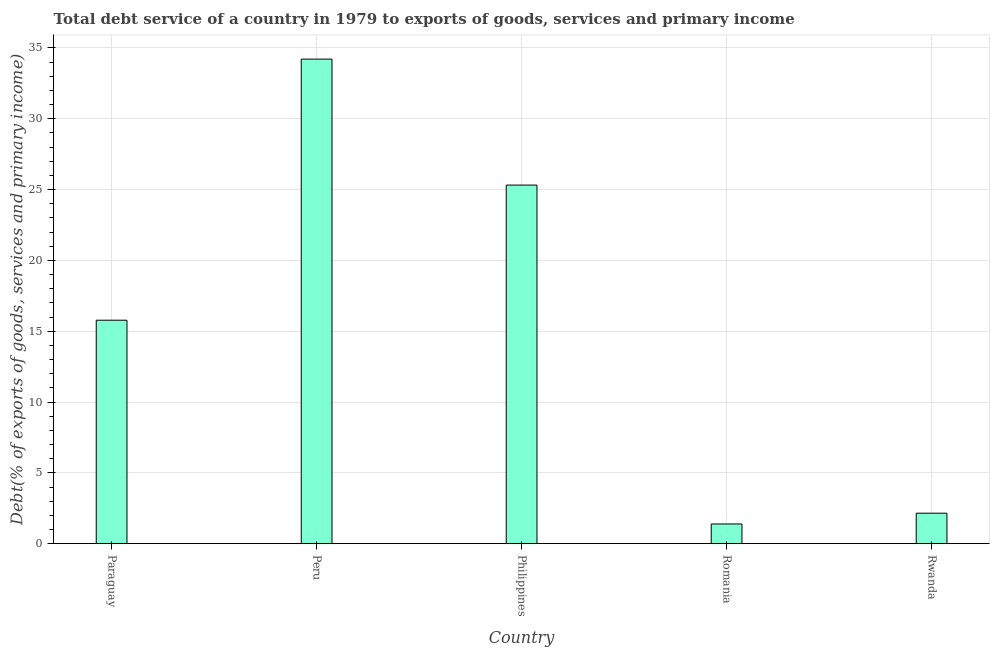What is the title of the graph?
Your response must be concise. Total debt service of a country in 1979 to exports of goods, services and primary income. What is the label or title of the Y-axis?
Your response must be concise. Debt(% of exports of goods, services and primary income). What is the total debt service in Philippines?
Ensure brevity in your answer.  25.32. Across all countries, what is the maximum total debt service?
Provide a short and direct response. 34.22. Across all countries, what is the minimum total debt service?
Give a very brief answer. 1.39. In which country was the total debt service maximum?
Ensure brevity in your answer.  Peru. In which country was the total debt service minimum?
Keep it short and to the point. Romania. What is the sum of the total debt service?
Provide a short and direct response. 78.86. What is the difference between the total debt service in Peru and Philippines?
Give a very brief answer. 8.9. What is the average total debt service per country?
Provide a succinct answer. 15.77. What is the median total debt service?
Ensure brevity in your answer.  15.78. What is the ratio of the total debt service in Philippines to that in Rwanda?
Your answer should be compact. 11.77. Is the total debt service in Romania less than that in Rwanda?
Provide a short and direct response. Yes. What is the difference between the highest and the second highest total debt service?
Make the answer very short. 8.9. What is the difference between the highest and the lowest total debt service?
Provide a succinct answer. 32.83. How many countries are there in the graph?
Your answer should be very brief. 5. What is the Debt(% of exports of goods, services and primary income) in Paraguay?
Your answer should be very brief. 15.78. What is the Debt(% of exports of goods, services and primary income) of Peru?
Provide a succinct answer. 34.22. What is the Debt(% of exports of goods, services and primary income) of Philippines?
Provide a short and direct response. 25.32. What is the Debt(% of exports of goods, services and primary income) in Romania?
Keep it short and to the point. 1.39. What is the Debt(% of exports of goods, services and primary income) in Rwanda?
Your answer should be very brief. 2.15. What is the difference between the Debt(% of exports of goods, services and primary income) in Paraguay and Peru?
Keep it short and to the point. -18.44. What is the difference between the Debt(% of exports of goods, services and primary income) in Paraguay and Philippines?
Provide a succinct answer. -9.54. What is the difference between the Debt(% of exports of goods, services and primary income) in Paraguay and Romania?
Give a very brief answer. 14.39. What is the difference between the Debt(% of exports of goods, services and primary income) in Paraguay and Rwanda?
Offer a very short reply. 13.63. What is the difference between the Debt(% of exports of goods, services and primary income) in Peru and Philippines?
Offer a very short reply. 8.9. What is the difference between the Debt(% of exports of goods, services and primary income) in Peru and Romania?
Provide a short and direct response. 32.83. What is the difference between the Debt(% of exports of goods, services and primary income) in Peru and Rwanda?
Provide a succinct answer. 32.06. What is the difference between the Debt(% of exports of goods, services and primary income) in Philippines and Romania?
Provide a short and direct response. 23.93. What is the difference between the Debt(% of exports of goods, services and primary income) in Philippines and Rwanda?
Your answer should be very brief. 23.17. What is the difference between the Debt(% of exports of goods, services and primary income) in Romania and Rwanda?
Your answer should be compact. -0.76. What is the ratio of the Debt(% of exports of goods, services and primary income) in Paraguay to that in Peru?
Your answer should be very brief. 0.46. What is the ratio of the Debt(% of exports of goods, services and primary income) in Paraguay to that in Philippines?
Provide a succinct answer. 0.62. What is the ratio of the Debt(% of exports of goods, services and primary income) in Paraguay to that in Romania?
Offer a terse response. 11.35. What is the ratio of the Debt(% of exports of goods, services and primary income) in Paraguay to that in Rwanda?
Ensure brevity in your answer.  7.33. What is the ratio of the Debt(% of exports of goods, services and primary income) in Peru to that in Philippines?
Provide a succinct answer. 1.35. What is the ratio of the Debt(% of exports of goods, services and primary income) in Peru to that in Romania?
Ensure brevity in your answer.  24.61. What is the ratio of the Debt(% of exports of goods, services and primary income) in Peru to that in Rwanda?
Make the answer very short. 15.91. What is the ratio of the Debt(% of exports of goods, services and primary income) in Philippines to that in Romania?
Keep it short and to the point. 18.21. What is the ratio of the Debt(% of exports of goods, services and primary income) in Philippines to that in Rwanda?
Make the answer very short. 11.77. What is the ratio of the Debt(% of exports of goods, services and primary income) in Romania to that in Rwanda?
Your response must be concise. 0.65. 